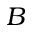<formula> <loc_0><loc_0><loc_500><loc_500>B</formula> 